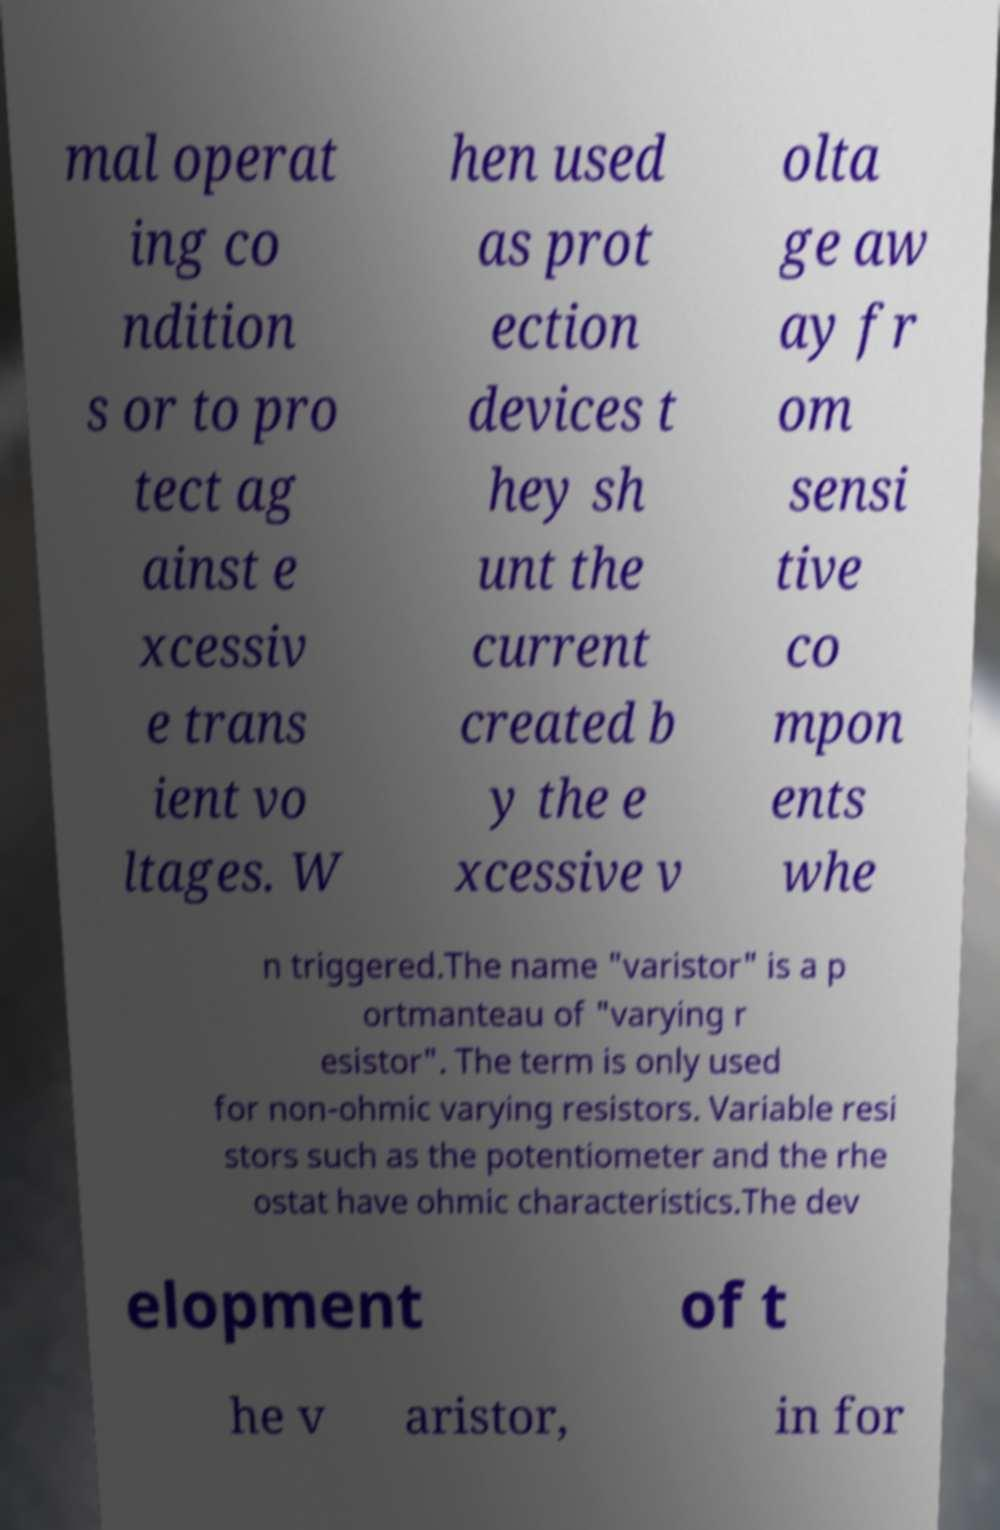Please read and relay the text visible in this image. What does it say? mal operat ing co ndition s or to pro tect ag ainst e xcessiv e trans ient vo ltages. W hen used as prot ection devices t hey sh unt the current created b y the e xcessive v olta ge aw ay fr om sensi tive co mpon ents whe n triggered.The name "varistor" is a p ortmanteau of "varying r esistor". The term is only used for non-ohmic varying resistors. Variable resi stors such as the potentiometer and the rhe ostat have ohmic characteristics.The dev elopment of t he v aristor, in for 